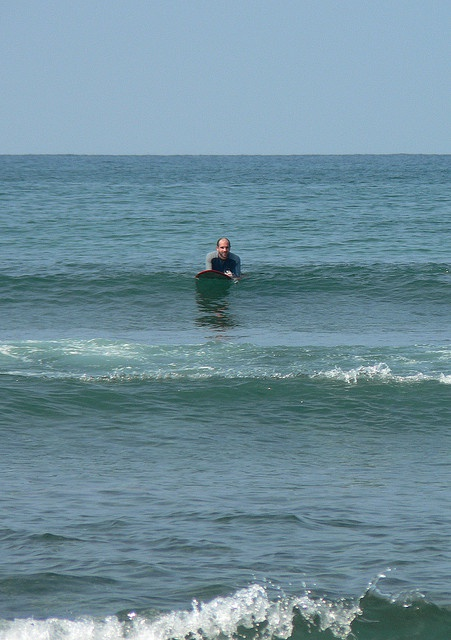Describe the objects in this image and their specific colors. I can see people in lightblue, black, darkgray, gray, and blue tones and surfboard in lightblue, black, gray, maroon, and teal tones in this image. 